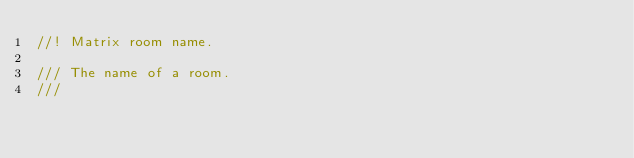<code> <loc_0><loc_0><loc_500><loc_500><_Rust_>//! Matrix room name.

/// The name of a room.
///</code> 